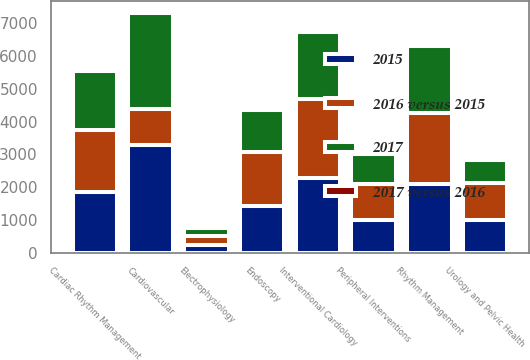Convert chart to OTSL. <chart><loc_0><loc_0><loc_500><loc_500><stacked_bar_chart><ecel><fcel>Interventional Cardiology<fcel>Peripheral Interventions<fcel>Cardiovascular<fcel>Cardiac Rhythm Management<fcel>Electrophysiology<fcel>Rhythm Management<fcel>Endoscopy<fcel>Urology and Pelvic Health<nl><fcel>2016 versus 2015<fcel>2419<fcel>1081<fcel>1081<fcel>1895<fcel>278<fcel>2173<fcel>1619<fcel>1124<nl><fcel>2015<fcel>2281<fcel>1011<fcel>3292<fcel>1850<fcel>243<fcel>2093<fcel>1440<fcel>1005<nl><fcel>2017<fcel>2033<fcel>904<fcel>2937<fcel>1807<fcel>233<fcel>2040<fcel>1306<fcel>693<nl><fcel>2017 versus 2016<fcel>6.1<fcel>6.8<fcel>6.3<fcel>2.5<fcel>14.5<fcel>3.9<fcel>12.4<fcel>11.8<nl></chart> 